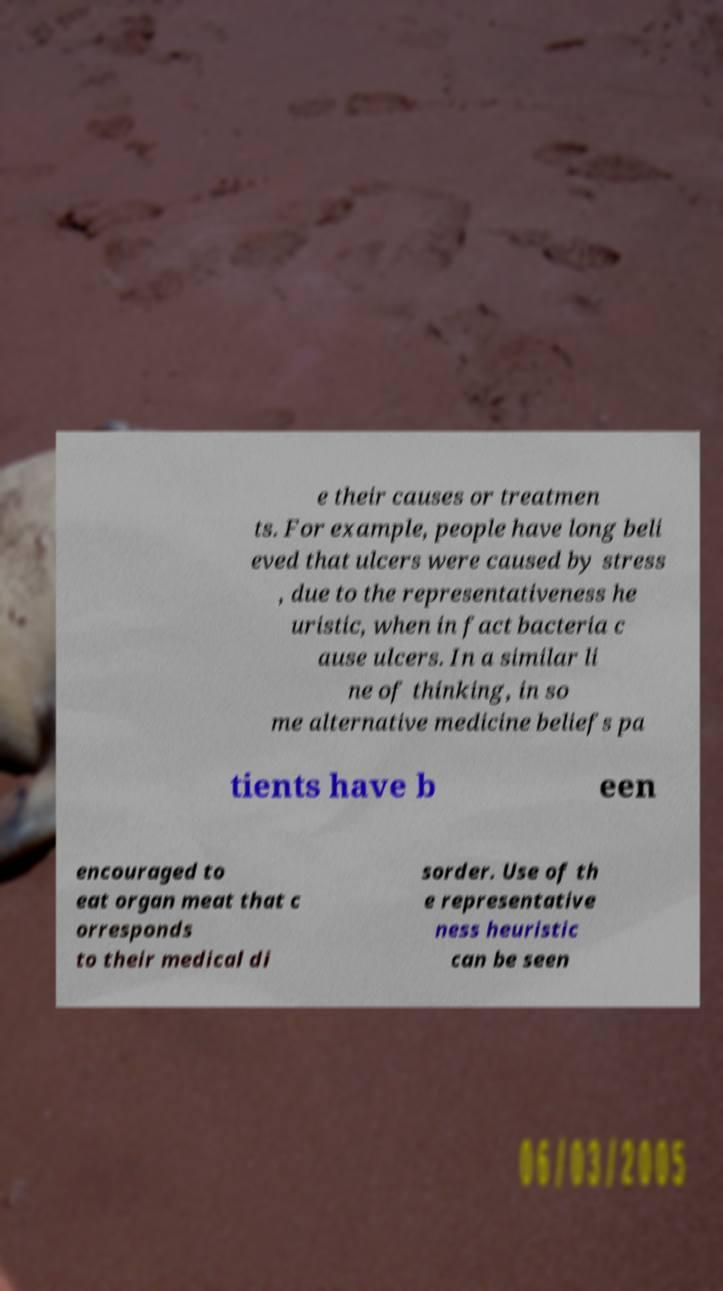There's text embedded in this image that I need extracted. Can you transcribe it verbatim? e their causes or treatmen ts. For example, people have long beli eved that ulcers were caused by stress , due to the representativeness he uristic, when in fact bacteria c ause ulcers. In a similar li ne of thinking, in so me alternative medicine beliefs pa tients have b een encouraged to eat organ meat that c orresponds to their medical di sorder. Use of th e representative ness heuristic can be seen 